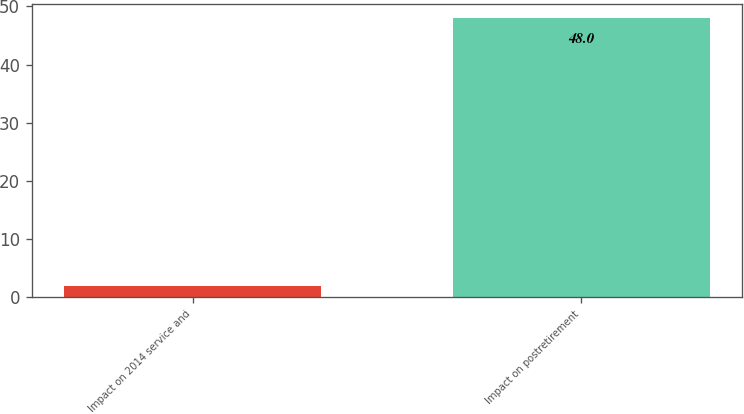<chart> <loc_0><loc_0><loc_500><loc_500><bar_chart><fcel>Impact on 2014 service and<fcel>Impact on postretirement<nl><fcel>2<fcel>48<nl></chart> 